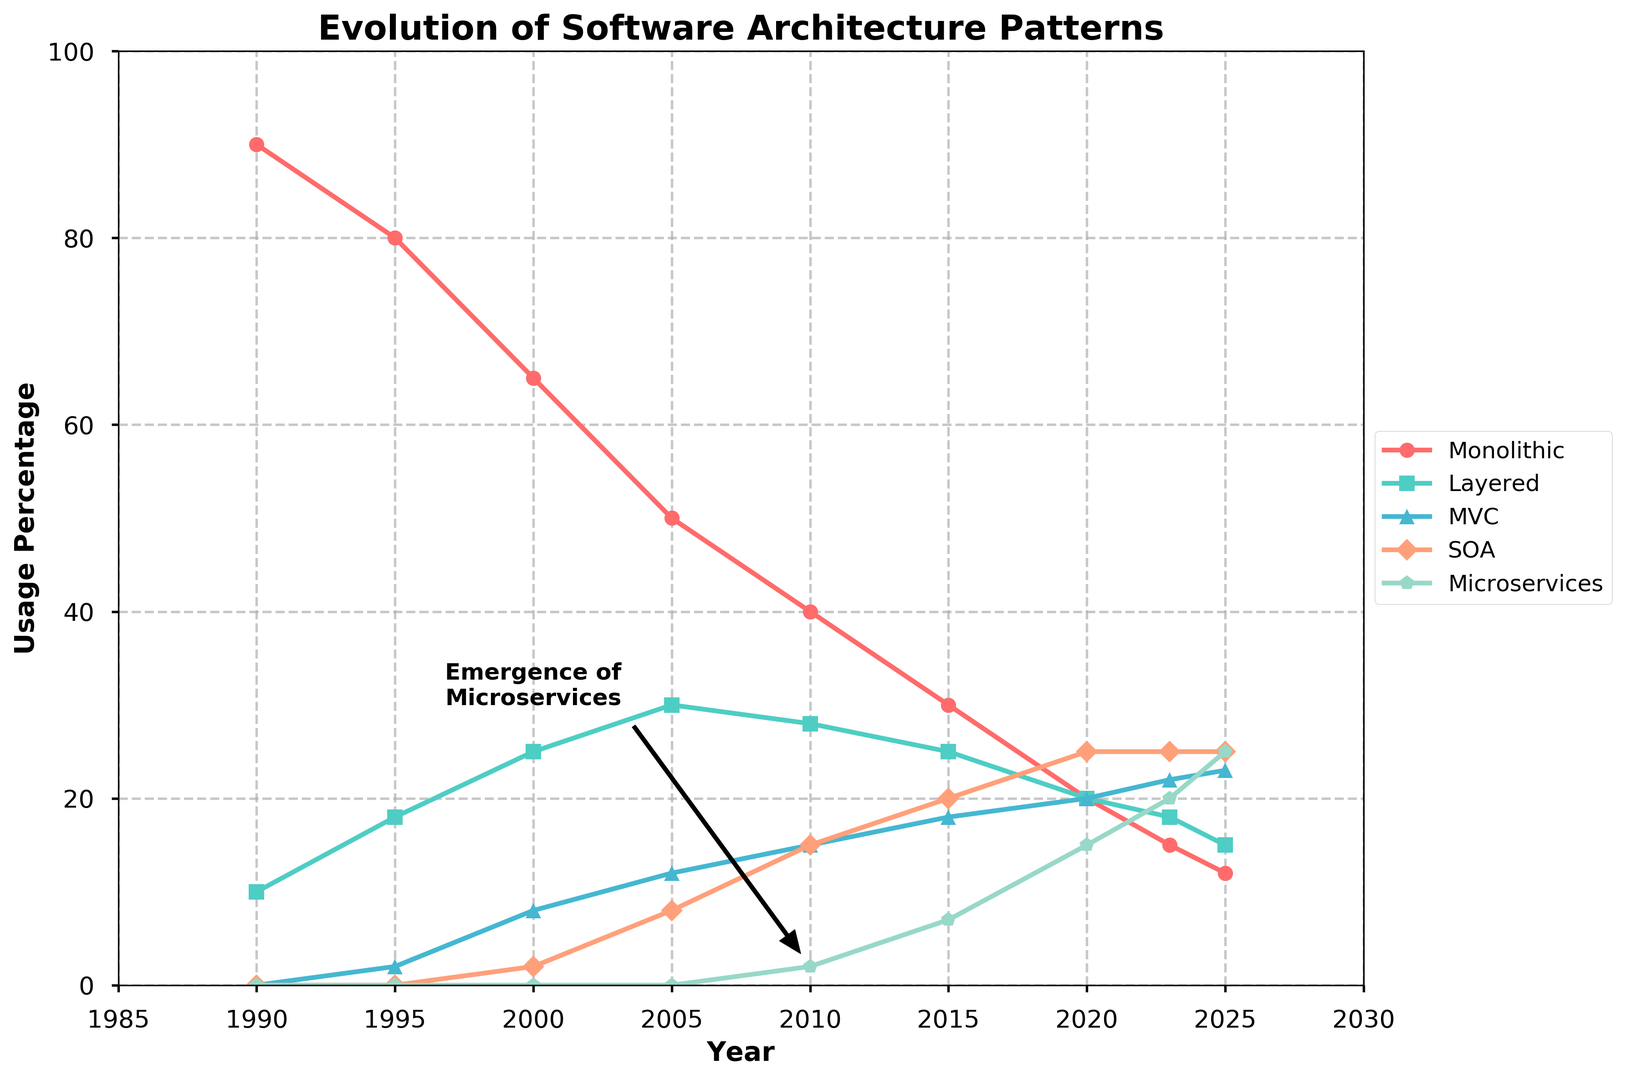What trend does the usage of microservices show from 2010 to 2025? Microservices usage begins at 2% in 2010, rises to 7% by 2015, increases to 15% by 2020, and reaches 25% by 2025. This shows a steady upward trend.
Answer: Upward trend Which software architecture pattern had the highest usage in 2000? By observing the different usage percentages in 2000, Monolithic is at 65%, Layered at 25%, MVC at 8%, SOA at 2%, and Microservices at 0%. Monolithic has the highest usage.
Answer: Monolithic How does the emergence of microservices in 2010 correlate with the usage trend of Monolithic architectures? In 2010, Microservices emerge with a 2% usage, while Monolithic architectures continue their declining trend, dropping from 40% to 30% in 2015. This suggests a shift away from Monolithic as Microservices gain traction.
Answer: Negative correlation Which two architecture patterns were used equally in 2020, and what was their usage percentage? In 2020, both Monolithic and MVC architect patterns each have a usage percentage of 20%.
Answer: Monolithic and MVC, 20% How did the usage of SOA evolve between 1990 and 2023? SOA starts at 0% in 1990, emerges with 2% usage in 2000, increases to 8% in 2005, rises steadily to 20% by 2015, and stabilizes at 25% by 2023.
Answer: Increasing trend What is the difference in usage percentage between Layered and MVC architectures in 2025? In 2025, Layered architecture has a usage percentage of 15% while MVC has a usage percentage of 23%. The difference between them is 23% - 15% = 8%.
Answer: 8% Between 2015 and 2020, which architecture pattern saw the largest increase in usage percentage? Comparing usage from 2015 to 2020: Monolithic drops from 30% to 20% (-10%), Layered decreases from 25% to 20% (-5%), MVC rises from 18% to 20% (+2%), SOA rises from 20% to 25% (+5%), and Microservices increase from 7% to 15% (+8%). Microservices saw the largest increase (+8%).
Answer: Microservices What annotation is highlighted in the plot and what does it signify? The annotation "Emergence of Microservices" points to the year 2010 at a 2% usage rate and explains the beginning of microservices being noted as a separate architecture pattern.
Answer: Emergence of Microservices in 2010 Which software architecture pattern maintained a steady usage percentage from 2020 to 2023, and what was this percentage? Examining the data from 2020 to 2023, SOA stays at 25% in both years.
Answer: SOA, 25% 